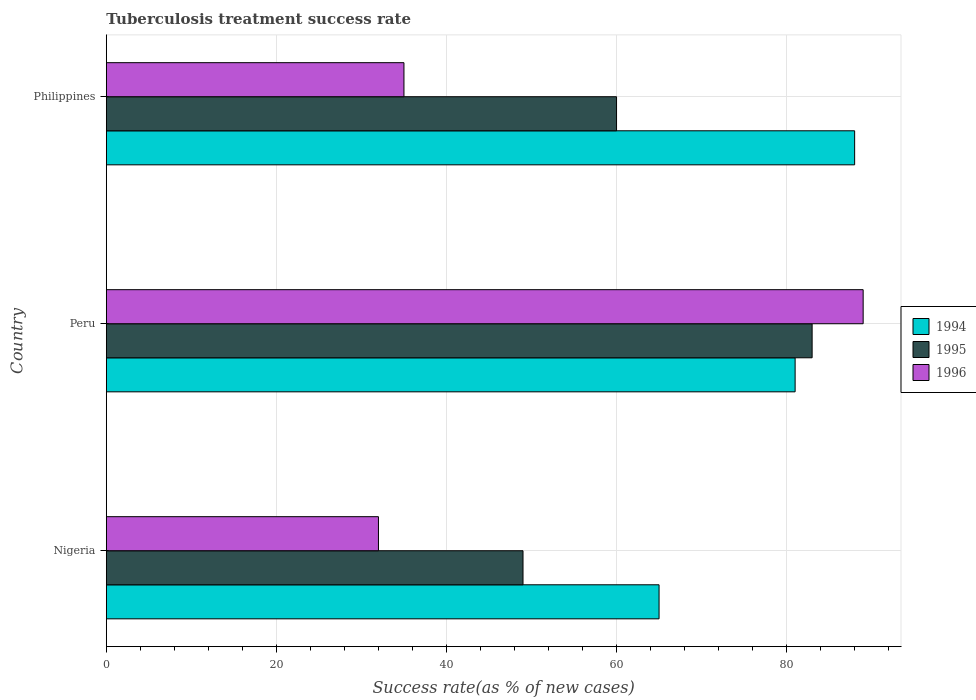How many groups of bars are there?
Ensure brevity in your answer.  3. Are the number of bars per tick equal to the number of legend labels?
Give a very brief answer. Yes. What is the label of the 3rd group of bars from the top?
Offer a terse response. Nigeria. What is the tuberculosis treatment success rate in 1994 in Peru?
Your response must be concise. 81. Across all countries, what is the maximum tuberculosis treatment success rate in 1994?
Offer a terse response. 88. Across all countries, what is the minimum tuberculosis treatment success rate in 1995?
Your answer should be very brief. 49. In which country was the tuberculosis treatment success rate in 1994 minimum?
Your answer should be compact. Nigeria. What is the total tuberculosis treatment success rate in 1994 in the graph?
Your answer should be very brief. 234. What is the difference between the tuberculosis treatment success rate in 1994 in Nigeria and that in Philippines?
Ensure brevity in your answer.  -23. What is the average tuberculosis treatment success rate in 1994 per country?
Your answer should be compact. 78. What is the ratio of the tuberculosis treatment success rate in 1996 in Nigeria to that in Peru?
Make the answer very short. 0.36. Is the difference between the tuberculosis treatment success rate in 1995 in Nigeria and Philippines greater than the difference between the tuberculosis treatment success rate in 1994 in Nigeria and Philippines?
Make the answer very short. Yes. What is the difference between the highest and the lowest tuberculosis treatment success rate in 1994?
Provide a short and direct response. 23. Is the sum of the tuberculosis treatment success rate in 1995 in Peru and Philippines greater than the maximum tuberculosis treatment success rate in 1996 across all countries?
Ensure brevity in your answer.  Yes. What does the 1st bar from the bottom in Peru represents?
Make the answer very short. 1994. Is it the case that in every country, the sum of the tuberculosis treatment success rate in 1994 and tuberculosis treatment success rate in 1995 is greater than the tuberculosis treatment success rate in 1996?
Your answer should be very brief. Yes. How many bars are there?
Your answer should be compact. 9. Are all the bars in the graph horizontal?
Your response must be concise. Yes. How many countries are there in the graph?
Provide a short and direct response. 3. What is the difference between two consecutive major ticks on the X-axis?
Your response must be concise. 20. Are the values on the major ticks of X-axis written in scientific E-notation?
Offer a terse response. No. Does the graph contain any zero values?
Ensure brevity in your answer.  No. How many legend labels are there?
Offer a very short reply. 3. How are the legend labels stacked?
Make the answer very short. Vertical. What is the title of the graph?
Ensure brevity in your answer.  Tuberculosis treatment success rate. Does "1968" appear as one of the legend labels in the graph?
Provide a succinct answer. No. What is the label or title of the X-axis?
Provide a succinct answer. Success rate(as % of new cases). What is the label or title of the Y-axis?
Your response must be concise. Country. What is the Success rate(as % of new cases) in 1994 in Nigeria?
Your response must be concise. 65. What is the Success rate(as % of new cases) of 1995 in Nigeria?
Keep it short and to the point. 49. What is the Success rate(as % of new cases) in 1994 in Peru?
Offer a very short reply. 81. What is the Success rate(as % of new cases) in 1995 in Peru?
Keep it short and to the point. 83. What is the Success rate(as % of new cases) of 1996 in Peru?
Provide a succinct answer. 89. What is the Success rate(as % of new cases) in 1996 in Philippines?
Give a very brief answer. 35. Across all countries, what is the maximum Success rate(as % of new cases) in 1994?
Make the answer very short. 88. Across all countries, what is the maximum Success rate(as % of new cases) of 1995?
Provide a short and direct response. 83. Across all countries, what is the maximum Success rate(as % of new cases) of 1996?
Offer a terse response. 89. Across all countries, what is the minimum Success rate(as % of new cases) of 1996?
Give a very brief answer. 32. What is the total Success rate(as % of new cases) of 1994 in the graph?
Your response must be concise. 234. What is the total Success rate(as % of new cases) in 1995 in the graph?
Offer a very short reply. 192. What is the total Success rate(as % of new cases) of 1996 in the graph?
Offer a terse response. 156. What is the difference between the Success rate(as % of new cases) of 1994 in Nigeria and that in Peru?
Offer a very short reply. -16. What is the difference between the Success rate(as % of new cases) of 1995 in Nigeria and that in Peru?
Offer a very short reply. -34. What is the difference between the Success rate(as % of new cases) of 1996 in Nigeria and that in Peru?
Offer a terse response. -57. What is the difference between the Success rate(as % of new cases) in 1994 in Nigeria and that in Philippines?
Give a very brief answer. -23. What is the difference between the Success rate(as % of new cases) in 1995 in Nigeria and that in Philippines?
Offer a very short reply. -11. What is the difference between the Success rate(as % of new cases) in 1994 in Nigeria and the Success rate(as % of new cases) in 1996 in Peru?
Your answer should be very brief. -24. What is the difference between the Success rate(as % of new cases) in 1995 in Nigeria and the Success rate(as % of new cases) in 1996 in Peru?
Ensure brevity in your answer.  -40. What is the difference between the Success rate(as % of new cases) of 1994 in Nigeria and the Success rate(as % of new cases) of 1996 in Philippines?
Offer a very short reply. 30. What is the difference between the Success rate(as % of new cases) of 1994 in Peru and the Success rate(as % of new cases) of 1995 in Philippines?
Your response must be concise. 21. What is the average Success rate(as % of new cases) of 1994 per country?
Your answer should be compact. 78. What is the average Success rate(as % of new cases) of 1995 per country?
Keep it short and to the point. 64. What is the average Success rate(as % of new cases) in 1996 per country?
Your response must be concise. 52. What is the difference between the Success rate(as % of new cases) in 1994 and Success rate(as % of new cases) in 1995 in Nigeria?
Ensure brevity in your answer.  16. What is the difference between the Success rate(as % of new cases) of 1994 and Success rate(as % of new cases) of 1996 in Nigeria?
Make the answer very short. 33. What is the difference between the Success rate(as % of new cases) in 1995 and Success rate(as % of new cases) in 1996 in Nigeria?
Your answer should be very brief. 17. What is the difference between the Success rate(as % of new cases) of 1994 and Success rate(as % of new cases) of 1995 in Peru?
Your answer should be very brief. -2. What is the difference between the Success rate(as % of new cases) of 1995 and Success rate(as % of new cases) of 1996 in Peru?
Your response must be concise. -6. What is the difference between the Success rate(as % of new cases) of 1994 and Success rate(as % of new cases) of 1996 in Philippines?
Your answer should be very brief. 53. What is the difference between the Success rate(as % of new cases) of 1995 and Success rate(as % of new cases) of 1996 in Philippines?
Give a very brief answer. 25. What is the ratio of the Success rate(as % of new cases) in 1994 in Nigeria to that in Peru?
Provide a succinct answer. 0.8. What is the ratio of the Success rate(as % of new cases) in 1995 in Nigeria to that in Peru?
Provide a short and direct response. 0.59. What is the ratio of the Success rate(as % of new cases) of 1996 in Nigeria to that in Peru?
Keep it short and to the point. 0.36. What is the ratio of the Success rate(as % of new cases) of 1994 in Nigeria to that in Philippines?
Make the answer very short. 0.74. What is the ratio of the Success rate(as % of new cases) of 1995 in Nigeria to that in Philippines?
Keep it short and to the point. 0.82. What is the ratio of the Success rate(as % of new cases) of 1996 in Nigeria to that in Philippines?
Ensure brevity in your answer.  0.91. What is the ratio of the Success rate(as % of new cases) of 1994 in Peru to that in Philippines?
Offer a terse response. 0.92. What is the ratio of the Success rate(as % of new cases) in 1995 in Peru to that in Philippines?
Provide a short and direct response. 1.38. What is the ratio of the Success rate(as % of new cases) of 1996 in Peru to that in Philippines?
Your response must be concise. 2.54. What is the difference between the highest and the second highest Success rate(as % of new cases) of 1995?
Make the answer very short. 23. What is the difference between the highest and the second highest Success rate(as % of new cases) in 1996?
Offer a very short reply. 54. What is the difference between the highest and the lowest Success rate(as % of new cases) of 1995?
Your answer should be compact. 34. What is the difference between the highest and the lowest Success rate(as % of new cases) in 1996?
Offer a terse response. 57. 